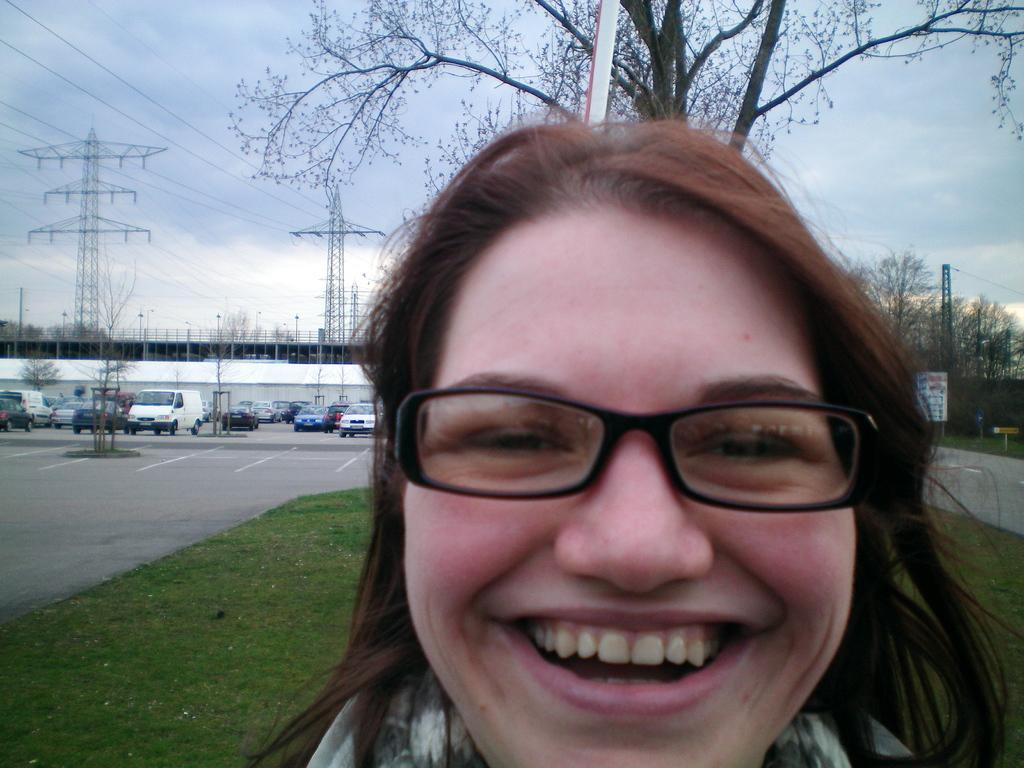Describe this image in one or two sentences. This picture is clicked outside. In the foreground there is a person wearing spectacles and smiling. In the background we can see the sky, cables, poles, trees, buildings, metal rods, boards and group of vehicles seems to be running on the road. 